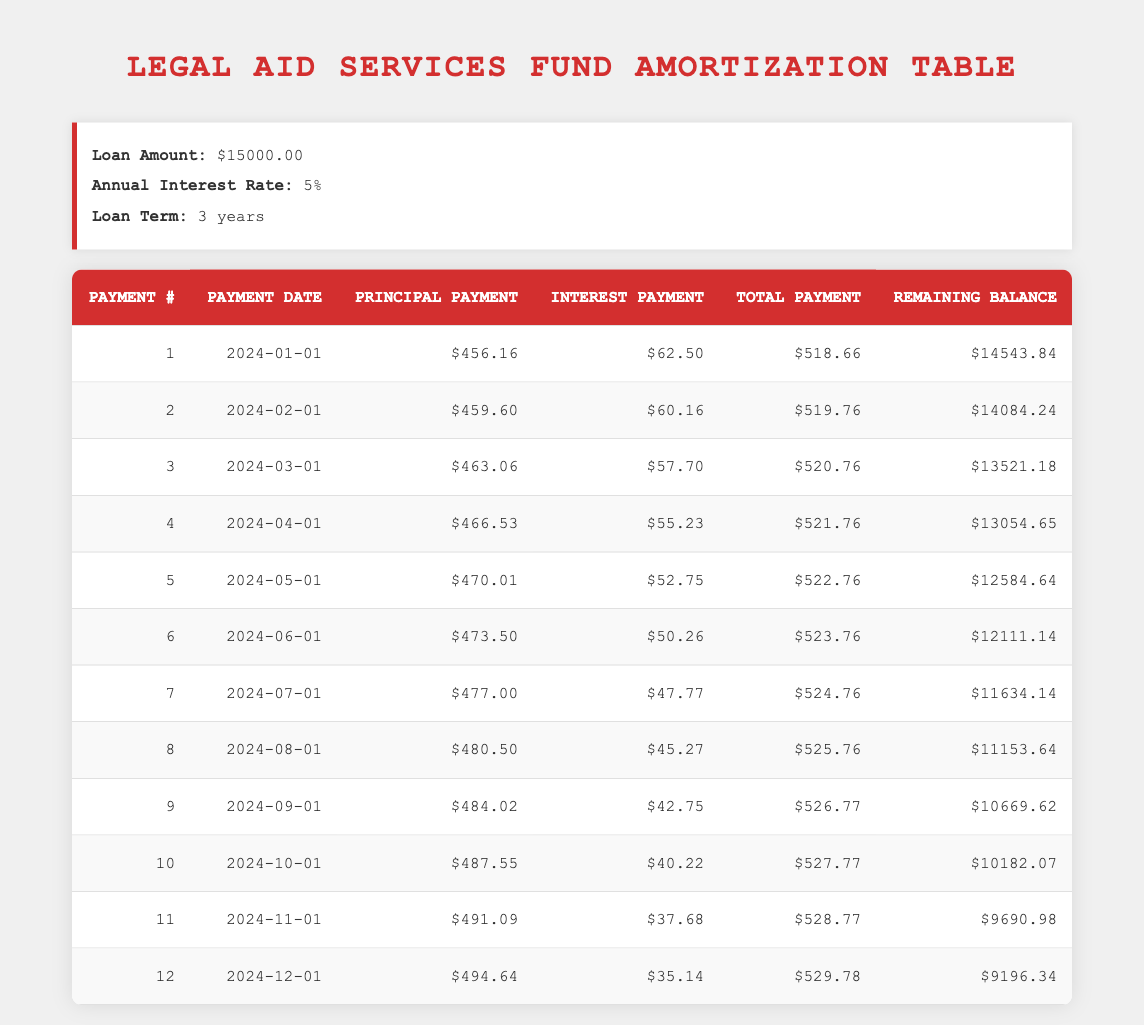What is the total payment for the first month? The total payment for the first month can be found in the table under the "Total Payment" column for payment number 1. It is 518.66.
Answer: 518.66 What was the principal payment in the sixth month? By looking at the sixth payment, the principal payment is listed in the "Principal Payment" column for payment number 6, which is 473.50.
Answer: 473.50 How much interest was paid in the third month? The interest payment in the third month can be found in the "Interest Payment" column for payment number 3. It is 57.70.
Answer: 57.70 What is the remaining balance after the fourth payment? The remaining balance after the fourth payment is the value in the "Remaining Balance" column for payment number 4, which is 13054.65.
Answer: 13054.65 What is the total principal paid after the first six months? To find the total principal paid after the first six months, we sum the principal payments for the first six months: 456.16 + 459.60 + 463.06 + 466.53 + 470.01 + 473.50 = 2888.86.
Answer: 2888.86 Is the total payment in the twelfth month higher than the total payment in the first month? By comparing the values, the total payment in the twelfth month is 529.78 and the total payment in the first month is 518.66. Since 529.78 is greater than 518.66, the answer is yes.
Answer: Yes What was the change in remaining balance from the second to the third month? The remaining balance for the second month is 14084.24 and for the third month is 13521.18. The change is calculated as 14084.24 - 13521.18 = 563.06, indicating a decrease.
Answer: 563.06 What was the average interest payment for the first six months? To calculate the average interest payment for the first six months, we sum the interest payments: 62.50 + 60.16 + 57.70 + 55.23 + 52.75 + 50.26 = 334.60. The average is then 334.60 / 6 = 55.77.
Answer: 55.77 Which month had the highest principal payment? By reviewing the principal payments from all twelve months, the highest principal payment occurs in the twelfth month at 494.64.
Answer: 494.64 